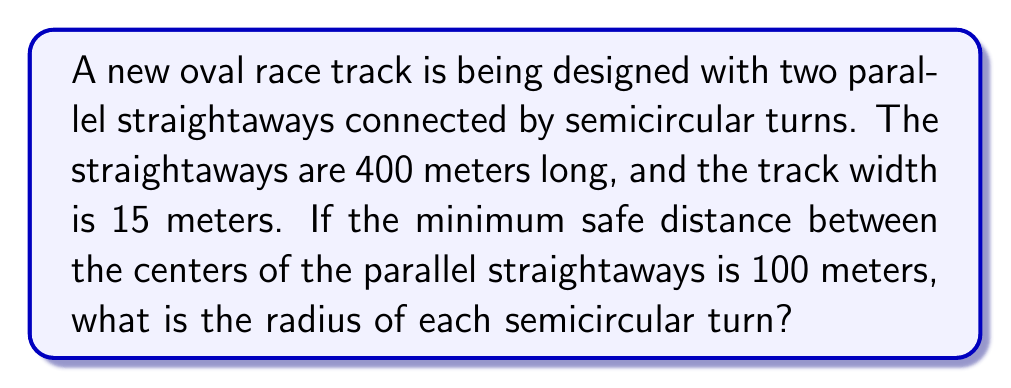Can you answer this question? Let's approach this step-by-step:

1) First, let's visualize the track. It consists of two parallel straightaways connected by semicircular turns at each end.

[asy]
size(200);
path p = (0,0)--(40,0)::arc((40,10),10,270,90)::(40,20)--(0,20)::arc((0,10),10,90,270)--cycle;
draw(p);
draw((0,10)--(40,10),dashed);
label("R", (0,10), W);
label("R", (40,10), E);
label("400 m", (20,0), S);
label("100 m", (20,10), N);
[/asy]

2) Let $R$ be the radius of each semicircular turn.

3) The distance between the centers of the parallel straightaways is given as 100 meters. This distance is equal to the diameter of the semicircle: $2R = 100$

4) From this, we can find $R$:
   
   $$R = \frac{100}{2} = 50\text{ meters}$$

5) However, this is the distance between the centers of the track. We need to account for the width of the track.

6) The track width is 15 meters. The center line of the track is half of this width (7.5 meters) inside the outer edge.

7) Therefore, the actual radius of the outer edge of the turn is:
   
   $$R_{\text{outer}} = 50 + 7.5 = 57.5\text{ meters}$$

This is the radius we're looking for, as it represents the minimum safe distance from the center of the turn to the outer edge of the track.
Answer: $57.5\text{ meters}$ 